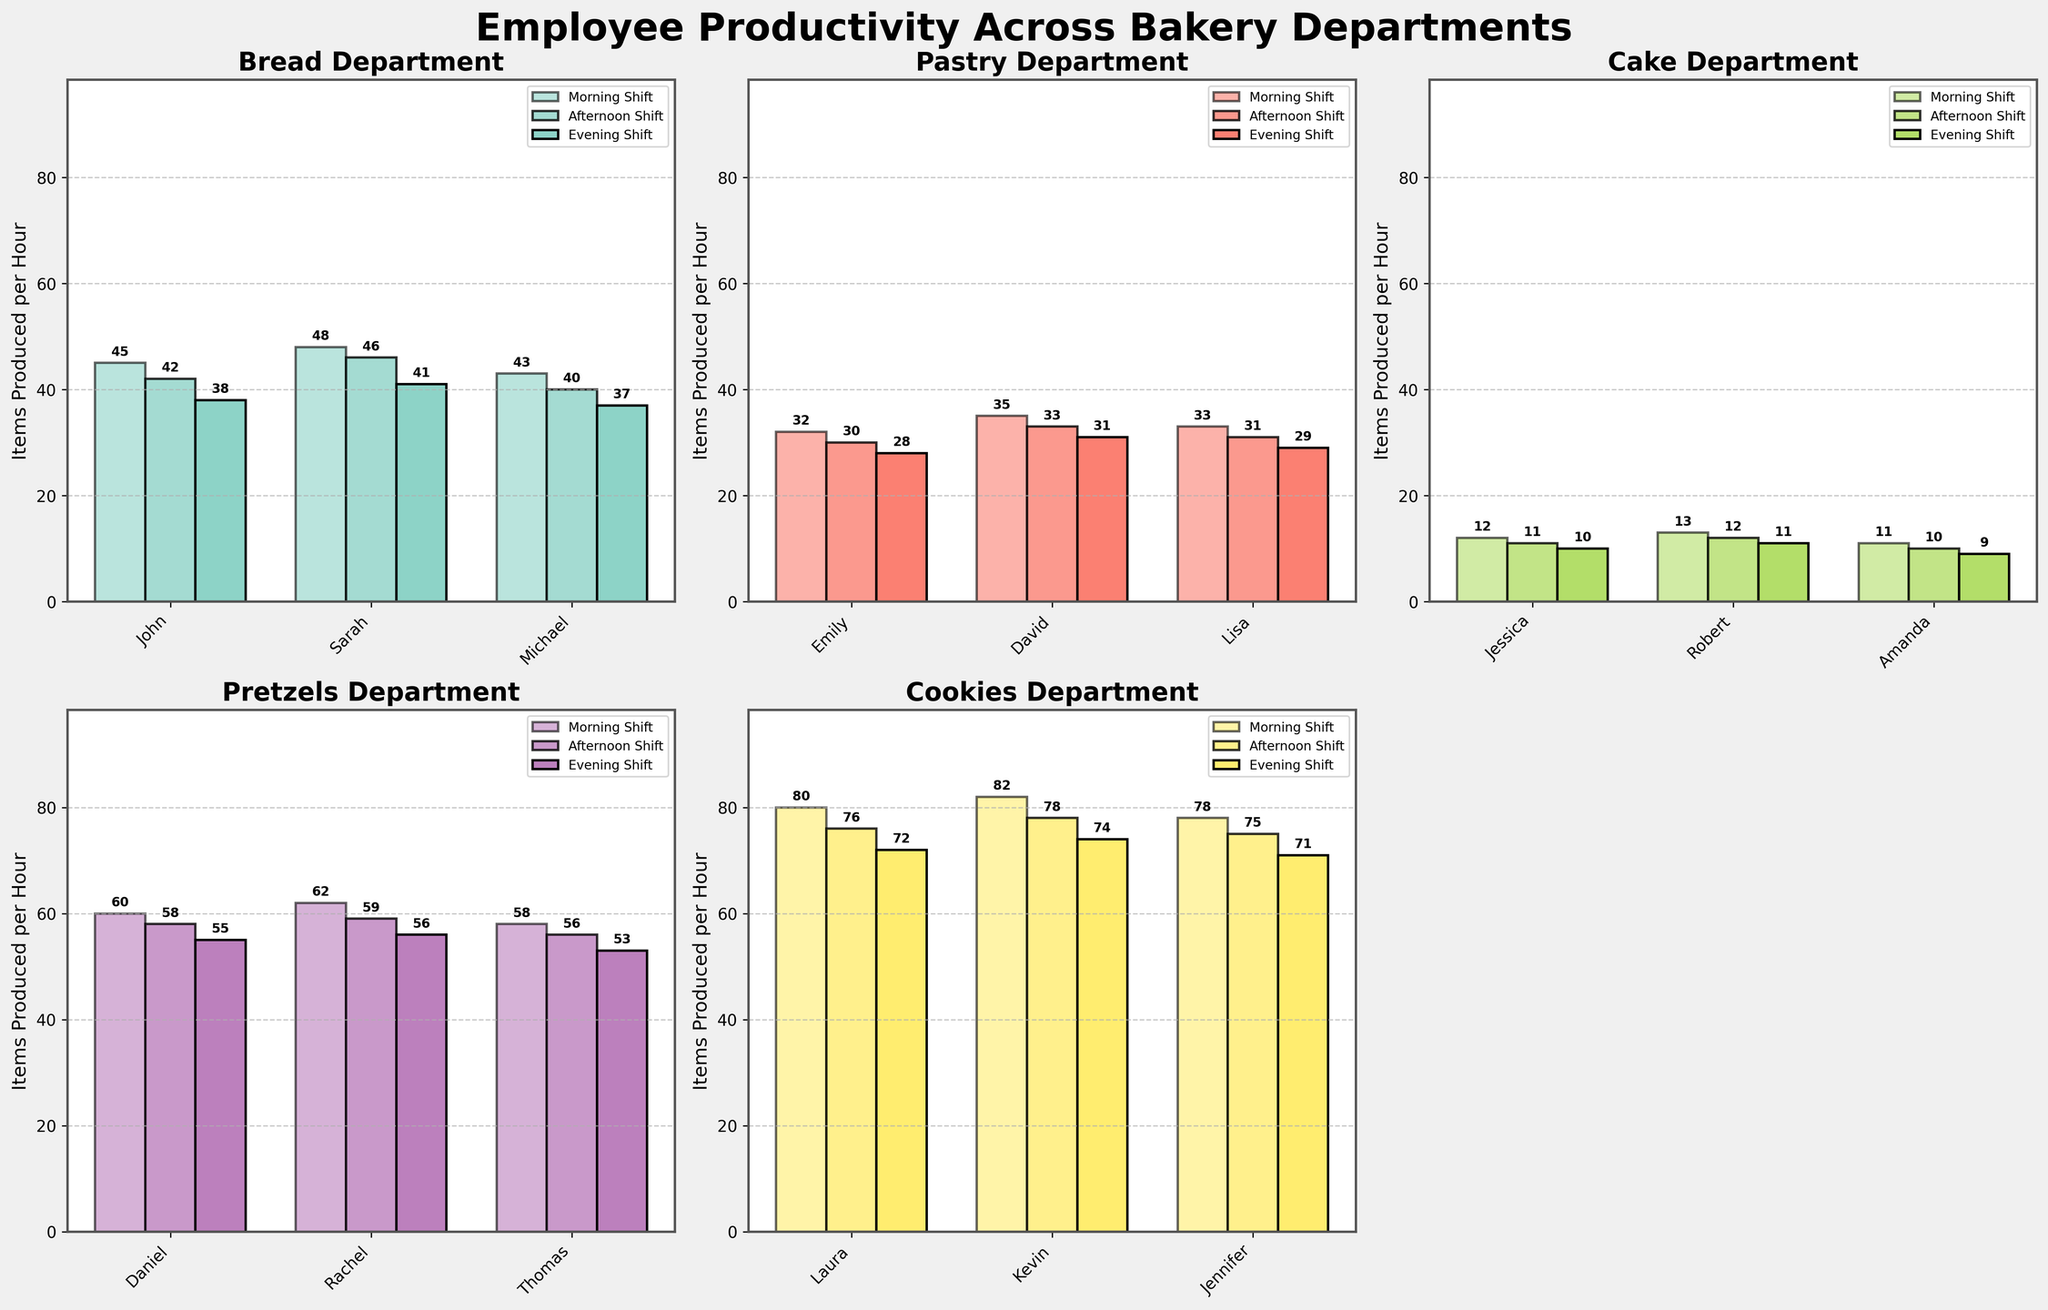How does the productivity of Sarah in the Bread department compare between the Morning and Evening shifts? To compare Sarah's productivity, we check the heights of the bars labeled with her name in the Bread department subplot. Sarah produces 48 items per hour in the Morning Shift and 41 items per hour in the Evening Shift. Thus, her productivity decreased.
Answer: 48 vs 41 Which employee in the Pastry department has the highest productivity in the Afternoon Shift? In the Pastry department subplot, we look at the bars corresponding to the Afternoon Shift for each employee. David has the highest bar, indicating he produces 33 items per hour.
Answer: David How many more items does Kevin in the Cookies department produce in the Morning Shift compared to the Evening Shift? We subtract Kevin's Evening Shift productivity from his Morning Shift productivity in the Cookies subplot. He produces 82 items per hour in the Morning Shift and 74 items per hour in the Evening Shift. 82 - 74 = 8.
Answer: 8 What's the average productivity of employees in the Pretzels department during the Afternoon Shift? To find the average, sum the Afternoon Shift productivities of Daniel, Rachel, and Thomas and divide by the number of employees. (58 + 59 + 56) / 3 = 173 / 3 = 57.67.
Answer: 57.67 Compare the productivity of Michael in the Bread department and David in the Pastry department during the Morning Shift. Who produces more items? Compare the heights of the Morning Shift bars for Michael in the Bread subplot and David in the Pastry subplot. Michael produces 43 items per hour, while David produces 35 items per hour. Michael is more productive.
Answer: Michael Which department has the highest productivity in the Morning Shift overall? Compare the heights of the tallest bars (Morning Shift) across all department subplots. The Cookies department has the highest bar for Kevin, who produces 82 items per hour.
Answer: Cookies What is the difference in productivity between the most and least productive employees in the Cake department during the Evening Shift? Compare Amanda’s (least productive) and Jessica’s (most productive) Evening Shift bars in the Cake department. Amanda produces 9, and Jessica produces 10 items per hour. 10 - 9 = 1.
Answer: 1 If you combine the total productivity of all employees in the Pretzels department during the Morning Shift, what is the result? Add the Morning Shift productivities of Daniel, Rachel, and Thomas in the Pretzels subplot. 60 + 62 + 58 = 180.
Answer: 180 Which employee has the least productivity in the Afternoon Shift across all departments? Identify the smallest Afternoon Shift bar across all subplots. Amanda in the Cake department produces 10 items per hour, which is the smallest.
Answer: Amanda 